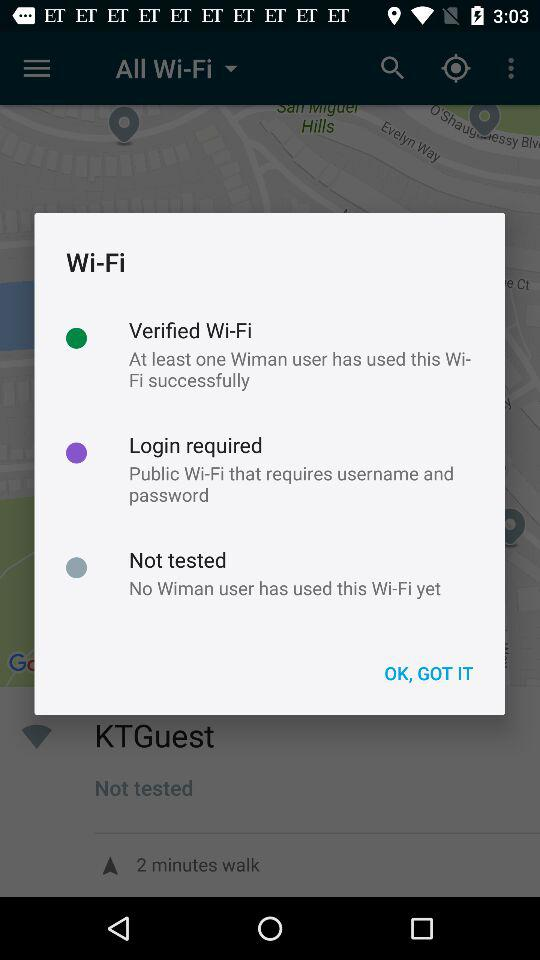What are the requirements for public Wi-Fi? The requirements for public Wi-Fi are a username and password. 